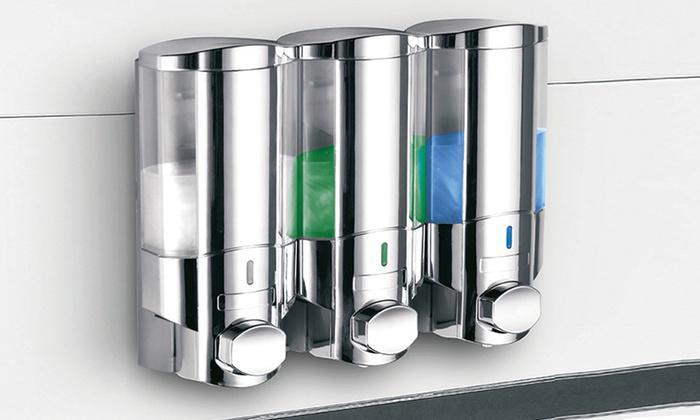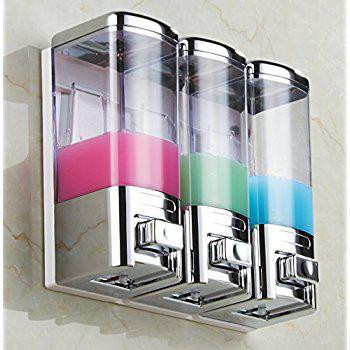The first image is the image on the left, the second image is the image on the right. Evaluate the accuracy of this statement regarding the images: "In a group of three shower soap dispensers, one contains green liquid soap.". Is it true? Answer yes or no. Yes. The first image is the image on the left, the second image is the image on the right. For the images shown, is this caption "There are at least six dispensers." true? Answer yes or no. Yes. 